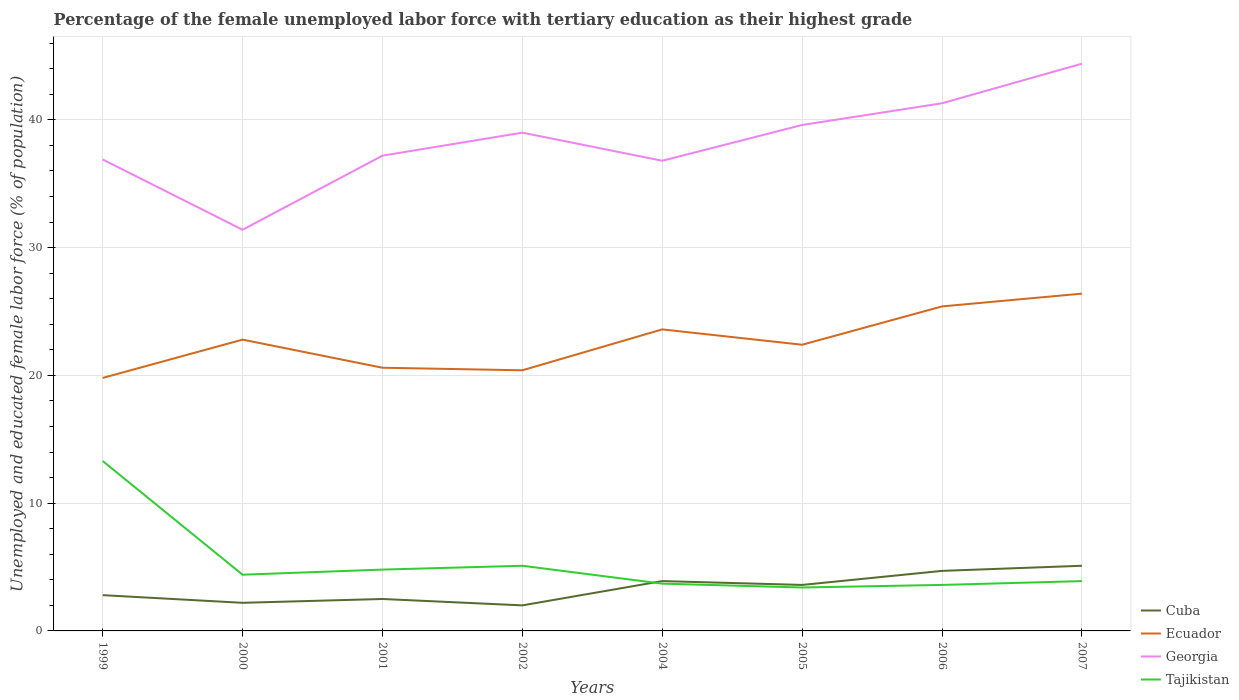How many different coloured lines are there?
Your response must be concise. 4. Does the line corresponding to Ecuador intersect with the line corresponding to Georgia?
Make the answer very short. No. Across all years, what is the maximum percentage of the unemployed female labor force with tertiary education in Georgia?
Give a very brief answer. 31.4. In which year was the percentage of the unemployed female labor force with tertiary education in Cuba maximum?
Provide a short and direct response. 2002. What is the total percentage of the unemployed female labor force with tertiary education in Ecuador in the graph?
Provide a succinct answer. -2.8. What is the difference between the highest and the second highest percentage of the unemployed female labor force with tertiary education in Ecuador?
Provide a succinct answer. 6.6. Is the percentage of the unemployed female labor force with tertiary education in Tajikistan strictly greater than the percentage of the unemployed female labor force with tertiary education in Ecuador over the years?
Keep it short and to the point. Yes. How many years are there in the graph?
Keep it short and to the point. 8. Does the graph contain any zero values?
Keep it short and to the point. No. Where does the legend appear in the graph?
Your answer should be very brief. Bottom right. What is the title of the graph?
Keep it short and to the point. Percentage of the female unemployed labor force with tertiary education as their highest grade. What is the label or title of the X-axis?
Provide a short and direct response. Years. What is the label or title of the Y-axis?
Your answer should be very brief. Unemployed and educated female labor force (% of population). What is the Unemployed and educated female labor force (% of population) of Cuba in 1999?
Your answer should be compact. 2.8. What is the Unemployed and educated female labor force (% of population) in Ecuador in 1999?
Give a very brief answer. 19.8. What is the Unemployed and educated female labor force (% of population) in Georgia in 1999?
Keep it short and to the point. 36.9. What is the Unemployed and educated female labor force (% of population) in Tajikistan in 1999?
Keep it short and to the point. 13.3. What is the Unemployed and educated female labor force (% of population) of Cuba in 2000?
Make the answer very short. 2.2. What is the Unemployed and educated female labor force (% of population) of Ecuador in 2000?
Your answer should be compact. 22.8. What is the Unemployed and educated female labor force (% of population) of Georgia in 2000?
Give a very brief answer. 31.4. What is the Unemployed and educated female labor force (% of population) of Tajikistan in 2000?
Provide a short and direct response. 4.4. What is the Unemployed and educated female labor force (% of population) in Cuba in 2001?
Offer a very short reply. 2.5. What is the Unemployed and educated female labor force (% of population) in Ecuador in 2001?
Give a very brief answer. 20.6. What is the Unemployed and educated female labor force (% of population) in Georgia in 2001?
Offer a very short reply. 37.2. What is the Unemployed and educated female labor force (% of population) of Tajikistan in 2001?
Make the answer very short. 4.8. What is the Unemployed and educated female labor force (% of population) in Ecuador in 2002?
Your response must be concise. 20.4. What is the Unemployed and educated female labor force (% of population) of Tajikistan in 2002?
Provide a short and direct response. 5.1. What is the Unemployed and educated female labor force (% of population) of Cuba in 2004?
Give a very brief answer. 3.9. What is the Unemployed and educated female labor force (% of population) in Ecuador in 2004?
Provide a succinct answer. 23.6. What is the Unemployed and educated female labor force (% of population) in Georgia in 2004?
Provide a succinct answer. 36.8. What is the Unemployed and educated female labor force (% of population) of Tajikistan in 2004?
Offer a very short reply. 3.7. What is the Unemployed and educated female labor force (% of population) of Cuba in 2005?
Your response must be concise. 3.6. What is the Unemployed and educated female labor force (% of population) in Ecuador in 2005?
Make the answer very short. 22.4. What is the Unemployed and educated female labor force (% of population) in Georgia in 2005?
Give a very brief answer. 39.6. What is the Unemployed and educated female labor force (% of population) in Tajikistan in 2005?
Your response must be concise. 3.4. What is the Unemployed and educated female labor force (% of population) of Cuba in 2006?
Provide a succinct answer. 4.7. What is the Unemployed and educated female labor force (% of population) of Ecuador in 2006?
Your answer should be compact. 25.4. What is the Unemployed and educated female labor force (% of population) in Georgia in 2006?
Offer a very short reply. 41.3. What is the Unemployed and educated female labor force (% of population) in Tajikistan in 2006?
Your response must be concise. 3.6. What is the Unemployed and educated female labor force (% of population) of Cuba in 2007?
Your response must be concise. 5.1. What is the Unemployed and educated female labor force (% of population) of Ecuador in 2007?
Offer a very short reply. 26.4. What is the Unemployed and educated female labor force (% of population) of Georgia in 2007?
Offer a very short reply. 44.4. What is the Unemployed and educated female labor force (% of population) in Tajikistan in 2007?
Keep it short and to the point. 3.9. Across all years, what is the maximum Unemployed and educated female labor force (% of population) of Cuba?
Give a very brief answer. 5.1. Across all years, what is the maximum Unemployed and educated female labor force (% of population) in Ecuador?
Your response must be concise. 26.4. Across all years, what is the maximum Unemployed and educated female labor force (% of population) of Georgia?
Offer a terse response. 44.4. Across all years, what is the maximum Unemployed and educated female labor force (% of population) in Tajikistan?
Your response must be concise. 13.3. Across all years, what is the minimum Unemployed and educated female labor force (% of population) in Cuba?
Keep it short and to the point. 2. Across all years, what is the minimum Unemployed and educated female labor force (% of population) in Ecuador?
Your answer should be compact. 19.8. Across all years, what is the minimum Unemployed and educated female labor force (% of population) of Georgia?
Provide a short and direct response. 31.4. Across all years, what is the minimum Unemployed and educated female labor force (% of population) of Tajikistan?
Your answer should be very brief. 3.4. What is the total Unemployed and educated female labor force (% of population) of Cuba in the graph?
Your response must be concise. 26.8. What is the total Unemployed and educated female labor force (% of population) of Ecuador in the graph?
Provide a short and direct response. 181.4. What is the total Unemployed and educated female labor force (% of population) in Georgia in the graph?
Provide a short and direct response. 306.6. What is the total Unemployed and educated female labor force (% of population) in Tajikistan in the graph?
Keep it short and to the point. 42.2. What is the difference between the Unemployed and educated female labor force (% of population) in Tajikistan in 1999 and that in 2000?
Make the answer very short. 8.9. What is the difference between the Unemployed and educated female labor force (% of population) of Tajikistan in 1999 and that in 2001?
Your answer should be very brief. 8.5. What is the difference between the Unemployed and educated female labor force (% of population) of Cuba in 1999 and that in 2002?
Provide a succinct answer. 0.8. What is the difference between the Unemployed and educated female labor force (% of population) in Ecuador in 1999 and that in 2002?
Provide a short and direct response. -0.6. What is the difference between the Unemployed and educated female labor force (% of population) of Georgia in 1999 and that in 2002?
Give a very brief answer. -2.1. What is the difference between the Unemployed and educated female labor force (% of population) in Tajikistan in 1999 and that in 2002?
Offer a terse response. 8.2. What is the difference between the Unemployed and educated female labor force (% of population) of Ecuador in 1999 and that in 2004?
Provide a succinct answer. -3.8. What is the difference between the Unemployed and educated female labor force (% of population) of Cuba in 1999 and that in 2005?
Give a very brief answer. -0.8. What is the difference between the Unemployed and educated female labor force (% of population) in Georgia in 1999 and that in 2005?
Keep it short and to the point. -2.7. What is the difference between the Unemployed and educated female labor force (% of population) in Cuba in 1999 and that in 2006?
Ensure brevity in your answer.  -1.9. What is the difference between the Unemployed and educated female labor force (% of population) of Georgia in 1999 and that in 2006?
Make the answer very short. -4.4. What is the difference between the Unemployed and educated female labor force (% of population) of Tajikistan in 1999 and that in 2006?
Your answer should be compact. 9.7. What is the difference between the Unemployed and educated female labor force (% of population) of Tajikistan in 1999 and that in 2007?
Give a very brief answer. 9.4. What is the difference between the Unemployed and educated female labor force (% of population) of Cuba in 2000 and that in 2001?
Make the answer very short. -0.3. What is the difference between the Unemployed and educated female labor force (% of population) of Georgia in 2000 and that in 2001?
Give a very brief answer. -5.8. What is the difference between the Unemployed and educated female labor force (% of population) of Georgia in 2000 and that in 2002?
Keep it short and to the point. -7.6. What is the difference between the Unemployed and educated female labor force (% of population) of Tajikistan in 2000 and that in 2002?
Your answer should be compact. -0.7. What is the difference between the Unemployed and educated female labor force (% of population) in Georgia in 2000 and that in 2004?
Provide a short and direct response. -5.4. What is the difference between the Unemployed and educated female labor force (% of population) of Tajikistan in 2000 and that in 2004?
Your answer should be compact. 0.7. What is the difference between the Unemployed and educated female labor force (% of population) in Georgia in 2000 and that in 2005?
Offer a very short reply. -8.2. What is the difference between the Unemployed and educated female labor force (% of population) in Tajikistan in 2000 and that in 2006?
Ensure brevity in your answer.  0.8. What is the difference between the Unemployed and educated female labor force (% of population) of Tajikistan in 2000 and that in 2007?
Ensure brevity in your answer.  0.5. What is the difference between the Unemployed and educated female labor force (% of population) of Ecuador in 2001 and that in 2002?
Your answer should be compact. 0.2. What is the difference between the Unemployed and educated female labor force (% of population) in Tajikistan in 2001 and that in 2002?
Provide a short and direct response. -0.3. What is the difference between the Unemployed and educated female labor force (% of population) in Tajikistan in 2001 and that in 2004?
Offer a very short reply. 1.1. What is the difference between the Unemployed and educated female labor force (% of population) in Cuba in 2001 and that in 2005?
Provide a short and direct response. -1.1. What is the difference between the Unemployed and educated female labor force (% of population) of Tajikistan in 2001 and that in 2005?
Ensure brevity in your answer.  1.4. What is the difference between the Unemployed and educated female labor force (% of population) in Ecuador in 2001 and that in 2006?
Give a very brief answer. -4.8. What is the difference between the Unemployed and educated female labor force (% of population) of Georgia in 2001 and that in 2006?
Offer a very short reply. -4.1. What is the difference between the Unemployed and educated female labor force (% of population) in Tajikistan in 2001 and that in 2006?
Keep it short and to the point. 1.2. What is the difference between the Unemployed and educated female labor force (% of population) in Tajikistan in 2001 and that in 2007?
Your response must be concise. 0.9. What is the difference between the Unemployed and educated female labor force (% of population) in Georgia in 2002 and that in 2004?
Ensure brevity in your answer.  2.2. What is the difference between the Unemployed and educated female labor force (% of population) of Cuba in 2002 and that in 2005?
Make the answer very short. -1.6. What is the difference between the Unemployed and educated female labor force (% of population) in Tajikistan in 2002 and that in 2005?
Offer a very short reply. 1.7. What is the difference between the Unemployed and educated female labor force (% of population) in Cuba in 2002 and that in 2006?
Make the answer very short. -2.7. What is the difference between the Unemployed and educated female labor force (% of population) in Ecuador in 2002 and that in 2006?
Offer a very short reply. -5. What is the difference between the Unemployed and educated female labor force (% of population) of Georgia in 2002 and that in 2006?
Offer a terse response. -2.3. What is the difference between the Unemployed and educated female labor force (% of population) in Tajikistan in 2002 and that in 2006?
Make the answer very short. 1.5. What is the difference between the Unemployed and educated female labor force (% of population) of Ecuador in 2002 and that in 2007?
Your answer should be very brief. -6. What is the difference between the Unemployed and educated female labor force (% of population) of Georgia in 2002 and that in 2007?
Offer a terse response. -5.4. What is the difference between the Unemployed and educated female labor force (% of population) of Tajikistan in 2004 and that in 2005?
Your answer should be very brief. 0.3. What is the difference between the Unemployed and educated female labor force (% of population) of Cuba in 2004 and that in 2006?
Make the answer very short. -0.8. What is the difference between the Unemployed and educated female labor force (% of population) of Ecuador in 2004 and that in 2006?
Offer a very short reply. -1.8. What is the difference between the Unemployed and educated female labor force (% of population) of Georgia in 2004 and that in 2006?
Provide a succinct answer. -4.5. What is the difference between the Unemployed and educated female labor force (% of population) of Tajikistan in 2004 and that in 2007?
Make the answer very short. -0.2. What is the difference between the Unemployed and educated female labor force (% of population) of Ecuador in 2005 and that in 2006?
Keep it short and to the point. -3. What is the difference between the Unemployed and educated female labor force (% of population) in Tajikistan in 2005 and that in 2006?
Ensure brevity in your answer.  -0.2. What is the difference between the Unemployed and educated female labor force (% of population) of Cuba in 2005 and that in 2007?
Your response must be concise. -1.5. What is the difference between the Unemployed and educated female labor force (% of population) in Ecuador in 2005 and that in 2007?
Give a very brief answer. -4. What is the difference between the Unemployed and educated female labor force (% of population) in Georgia in 2005 and that in 2007?
Your response must be concise. -4.8. What is the difference between the Unemployed and educated female labor force (% of population) of Cuba in 2006 and that in 2007?
Your response must be concise. -0.4. What is the difference between the Unemployed and educated female labor force (% of population) in Georgia in 2006 and that in 2007?
Provide a succinct answer. -3.1. What is the difference between the Unemployed and educated female labor force (% of population) of Tajikistan in 2006 and that in 2007?
Ensure brevity in your answer.  -0.3. What is the difference between the Unemployed and educated female labor force (% of population) of Cuba in 1999 and the Unemployed and educated female labor force (% of population) of Ecuador in 2000?
Provide a short and direct response. -20. What is the difference between the Unemployed and educated female labor force (% of population) of Cuba in 1999 and the Unemployed and educated female labor force (% of population) of Georgia in 2000?
Your response must be concise. -28.6. What is the difference between the Unemployed and educated female labor force (% of population) of Cuba in 1999 and the Unemployed and educated female labor force (% of population) of Tajikistan in 2000?
Your answer should be very brief. -1.6. What is the difference between the Unemployed and educated female labor force (% of population) of Ecuador in 1999 and the Unemployed and educated female labor force (% of population) of Georgia in 2000?
Offer a very short reply. -11.6. What is the difference between the Unemployed and educated female labor force (% of population) in Ecuador in 1999 and the Unemployed and educated female labor force (% of population) in Tajikistan in 2000?
Your answer should be very brief. 15.4. What is the difference between the Unemployed and educated female labor force (% of population) in Georgia in 1999 and the Unemployed and educated female labor force (% of population) in Tajikistan in 2000?
Keep it short and to the point. 32.5. What is the difference between the Unemployed and educated female labor force (% of population) of Cuba in 1999 and the Unemployed and educated female labor force (% of population) of Ecuador in 2001?
Ensure brevity in your answer.  -17.8. What is the difference between the Unemployed and educated female labor force (% of population) of Cuba in 1999 and the Unemployed and educated female labor force (% of population) of Georgia in 2001?
Ensure brevity in your answer.  -34.4. What is the difference between the Unemployed and educated female labor force (% of population) in Cuba in 1999 and the Unemployed and educated female labor force (% of population) in Tajikistan in 2001?
Your response must be concise. -2. What is the difference between the Unemployed and educated female labor force (% of population) of Ecuador in 1999 and the Unemployed and educated female labor force (% of population) of Georgia in 2001?
Ensure brevity in your answer.  -17.4. What is the difference between the Unemployed and educated female labor force (% of population) in Ecuador in 1999 and the Unemployed and educated female labor force (% of population) in Tajikistan in 2001?
Your answer should be very brief. 15. What is the difference between the Unemployed and educated female labor force (% of population) in Georgia in 1999 and the Unemployed and educated female labor force (% of population) in Tajikistan in 2001?
Give a very brief answer. 32.1. What is the difference between the Unemployed and educated female labor force (% of population) in Cuba in 1999 and the Unemployed and educated female labor force (% of population) in Ecuador in 2002?
Your answer should be very brief. -17.6. What is the difference between the Unemployed and educated female labor force (% of population) of Cuba in 1999 and the Unemployed and educated female labor force (% of population) of Georgia in 2002?
Your response must be concise. -36.2. What is the difference between the Unemployed and educated female labor force (% of population) in Cuba in 1999 and the Unemployed and educated female labor force (% of population) in Tajikistan in 2002?
Provide a succinct answer. -2.3. What is the difference between the Unemployed and educated female labor force (% of population) in Ecuador in 1999 and the Unemployed and educated female labor force (% of population) in Georgia in 2002?
Your answer should be very brief. -19.2. What is the difference between the Unemployed and educated female labor force (% of population) of Ecuador in 1999 and the Unemployed and educated female labor force (% of population) of Tajikistan in 2002?
Provide a short and direct response. 14.7. What is the difference between the Unemployed and educated female labor force (% of population) of Georgia in 1999 and the Unemployed and educated female labor force (% of population) of Tajikistan in 2002?
Make the answer very short. 31.8. What is the difference between the Unemployed and educated female labor force (% of population) of Cuba in 1999 and the Unemployed and educated female labor force (% of population) of Ecuador in 2004?
Your answer should be compact. -20.8. What is the difference between the Unemployed and educated female labor force (% of population) of Cuba in 1999 and the Unemployed and educated female labor force (% of population) of Georgia in 2004?
Offer a terse response. -34. What is the difference between the Unemployed and educated female labor force (% of population) of Ecuador in 1999 and the Unemployed and educated female labor force (% of population) of Georgia in 2004?
Give a very brief answer. -17. What is the difference between the Unemployed and educated female labor force (% of population) of Ecuador in 1999 and the Unemployed and educated female labor force (% of population) of Tajikistan in 2004?
Provide a short and direct response. 16.1. What is the difference between the Unemployed and educated female labor force (% of population) of Georgia in 1999 and the Unemployed and educated female labor force (% of population) of Tajikistan in 2004?
Ensure brevity in your answer.  33.2. What is the difference between the Unemployed and educated female labor force (% of population) in Cuba in 1999 and the Unemployed and educated female labor force (% of population) in Ecuador in 2005?
Offer a very short reply. -19.6. What is the difference between the Unemployed and educated female labor force (% of population) in Cuba in 1999 and the Unemployed and educated female labor force (% of population) in Georgia in 2005?
Provide a short and direct response. -36.8. What is the difference between the Unemployed and educated female labor force (% of population) in Ecuador in 1999 and the Unemployed and educated female labor force (% of population) in Georgia in 2005?
Your response must be concise. -19.8. What is the difference between the Unemployed and educated female labor force (% of population) of Georgia in 1999 and the Unemployed and educated female labor force (% of population) of Tajikistan in 2005?
Give a very brief answer. 33.5. What is the difference between the Unemployed and educated female labor force (% of population) of Cuba in 1999 and the Unemployed and educated female labor force (% of population) of Ecuador in 2006?
Make the answer very short. -22.6. What is the difference between the Unemployed and educated female labor force (% of population) of Cuba in 1999 and the Unemployed and educated female labor force (% of population) of Georgia in 2006?
Your answer should be compact. -38.5. What is the difference between the Unemployed and educated female labor force (% of population) of Cuba in 1999 and the Unemployed and educated female labor force (% of population) of Tajikistan in 2006?
Your response must be concise. -0.8. What is the difference between the Unemployed and educated female labor force (% of population) in Ecuador in 1999 and the Unemployed and educated female labor force (% of population) in Georgia in 2006?
Offer a very short reply. -21.5. What is the difference between the Unemployed and educated female labor force (% of population) in Ecuador in 1999 and the Unemployed and educated female labor force (% of population) in Tajikistan in 2006?
Your answer should be compact. 16.2. What is the difference between the Unemployed and educated female labor force (% of population) in Georgia in 1999 and the Unemployed and educated female labor force (% of population) in Tajikistan in 2006?
Give a very brief answer. 33.3. What is the difference between the Unemployed and educated female labor force (% of population) in Cuba in 1999 and the Unemployed and educated female labor force (% of population) in Ecuador in 2007?
Ensure brevity in your answer.  -23.6. What is the difference between the Unemployed and educated female labor force (% of population) of Cuba in 1999 and the Unemployed and educated female labor force (% of population) of Georgia in 2007?
Your answer should be compact. -41.6. What is the difference between the Unemployed and educated female labor force (% of population) in Ecuador in 1999 and the Unemployed and educated female labor force (% of population) in Georgia in 2007?
Ensure brevity in your answer.  -24.6. What is the difference between the Unemployed and educated female labor force (% of population) of Ecuador in 1999 and the Unemployed and educated female labor force (% of population) of Tajikistan in 2007?
Your answer should be very brief. 15.9. What is the difference between the Unemployed and educated female labor force (% of population) of Georgia in 1999 and the Unemployed and educated female labor force (% of population) of Tajikistan in 2007?
Make the answer very short. 33. What is the difference between the Unemployed and educated female labor force (% of population) in Cuba in 2000 and the Unemployed and educated female labor force (% of population) in Ecuador in 2001?
Provide a short and direct response. -18.4. What is the difference between the Unemployed and educated female labor force (% of population) of Cuba in 2000 and the Unemployed and educated female labor force (% of population) of Georgia in 2001?
Provide a succinct answer. -35. What is the difference between the Unemployed and educated female labor force (% of population) in Cuba in 2000 and the Unemployed and educated female labor force (% of population) in Tajikistan in 2001?
Make the answer very short. -2.6. What is the difference between the Unemployed and educated female labor force (% of population) in Ecuador in 2000 and the Unemployed and educated female labor force (% of population) in Georgia in 2001?
Provide a short and direct response. -14.4. What is the difference between the Unemployed and educated female labor force (% of population) of Ecuador in 2000 and the Unemployed and educated female labor force (% of population) of Tajikistan in 2001?
Ensure brevity in your answer.  18. What is the difference between the Unemployed and educated female labor force (% of population) in Georgia in 2000 and the Unemployed and educated female labor force (% of population) in Tajikistan in 2001?
Your answer should be compact. 26.6. What is the difference between the Unemployed and educated female labor force (% of population) in Cuba in 2000 and the Unemployed and educated female labor force (% of population) in Ecuador in 2002?
Your answer should be compact. -18.2. What is the difference between the Unemployed and educated female labor force (% of population) in Cuba in 2000 and the Unemployed and educated female labor force (% of population) in Georgia in 2002?
Your answer should be compact. -36.8. What is the difference between the Unemployed and educated female labor force (% of population) of Ecuador in 2000 and the Unemployed and educated female labor force (% of population) of Georgia in 2002?
Ensure brevity in your answer.  -16.2. What is the difference between the Unemployed and educated female labor force (% of population) in Ecuador in 2000 and the Unemployed and educated female labor force (% of population) in Tajikistan in 2002?
Ensure brevity in your answer.  17.7. What is the difference between the Unemployed and educated female labor force (% of population) in Georgia in 2000 and the Unemployed and educated female labor force (% of population) in Tajikistan in 2002?
Offer a very short reply. 26.3. What is the difference between the Unemployed and educated female labor force (% of population) in Cuba in 2000 and the Unemployed and educated female labor force (% of population) in Ecuador in 2004?
Provide a succinct answer. -21.4. What is the difference between the Unemployed and educated female labor force (% of population) of Cuba in 2000 and the Unemployed and educated female labor force (% of population) of Georgia in 2004?
Your answer should be compact. -34.6. What is the difference between the Unemployed and educated female labor force (% of population) in Cuba in 2000 and the Unemployed and educated female labor force (% of population) in Tajikistan in 2004?
Make the answer very short. -1.5. What is the difference between the Unemployed and educated female labor force (% of population) in Ecuador in 2000 and the Unemployed and educated female labor force (% of population) in Georgia in 2004?
Provide a short and direct response. -14. What is the difference between the Unemployed and educated female labor force (% of population) of Ecuador in 2000 and the Unemployed and educated female labor force (% of population) of Tajikistan in 2004?
Keep it short and to the point. 19.1. What is the difference between the Unemployed and educated female labor force (% of population) of Georgia in 2000 and the Unemployed and educated female labor force (% of population) of Tajikistan in 2004?
Offer a very short reply. 27.7. What is the difference between the Unemployed and educated female labor force (% of population) of Cuba in 2000 and the Unemployed and educated female labor force (% of population) of Ecuador in 2005?
Keep it short and to the point. -20.2. What is the difference between the Unemployed and educated female labor force (% of population) in Cuba in 2000 and the Unemployed and educated female labor force (% of population) in Georgia in 2005?
Offer a terse response. -37.4. What is the difference between the Unemployed and educated female labor force (% of population) of Ecuador in 2000 and the Unemployed and educated female labor force (% of population) of Georgia in 2005?
Give a very brief answer. -16.8. What is the difference between the Unemployed and educated female labor force (% of population) in Cuba in 2000 and the Unemployed and educated female labor force (% of population) in Ecuador in 2006?
Your answer should be compact. -23.2. What is the difference between the Unemployed and educated female labor force (% of population) of Cuba in 2000 and the Unemployed and educated female labor force (% of population) of Georgia in 2006?
Your response must be concise. -39.1. What is the difference between the Unemployed and educated female labor force (% of population) of Ecuador in 2000 and the Unemployed and educated female labor force (% of population) of Georgia in 2006?
Give a very brief answer. -18.5. What is the difference between the Unemployed and educated female labor force (% of population) in Ecuador in 2000 and the Unemployed and educated female labor force (% of population) in Tajikistan in 2006?
Offer a terse response. 19.2. What is the difference between the Unemployed and educated female labor force (% of population) in Georgia in 2000 and the Unemployed and educated female labor force (% of population) in Tajikistan in 2006?
Make the answer very short. 27.8. What is the difference between the Unemployed and educated female labor force (% of population) in Cuba in 2000 and the Unemployed and educated female labor force (% of population) in Ecuador in 2007?
Your answer should be compact. -24.2. What is the difference between the Unemployed and educated female labor force (% of population) in Cuba in 2000 and the Unemployed and educated female labor force (% of population) in Georgia in 2007?
Ensure brevity in your answer.  -42.2. What is the difference between the Unemployed and educated female labor force (% of population) of Cuba in 2000 and the Unemployed and educated female labor force (% of population) of Tajikistan in 2007?
Keep it short and to the point. -1.7. What is the difference between the Unemployed and educated female labor force (% of population) of Ecuador in 2000 and the Unemployed and educated female labor force (% of population) of Georgia in 2007?
Offer a very short reply. -21.6. What is the difference between the Unemployed and educated female labor force (% of population) of Cuba in 2001 and the Unemployed and educated female labor force (% of population) of Ecuador in 2002?
Make the answer very short. -17.9. What is the difference between the Unemployed and educated female labor force (% of population) of Cuba in 2001 and the Unemployed and educated female labor force (% of population) of Georgia in 2002?
Provide a short and direct response. -36.5. What is the difference between the Unemployed and educated female labor force (% of population) in Cuba in 2001 and the Unemployed and educated female labor force (% of population) in Tajikistan in 2002?
Provide a succinct answer. -2.6. What is the difference between the Unemployed and educated female labor force (% of population) of Ecuador in 2001 and the Unemployed and educated female labor force (% of population) of Georgia in 2002?
Your answer should be very brief. -18.4. What is the difference between the Unemployed and educated female labor force (% of population) of Ecuador in 2001 and the Unemployed and educated female labor force (% of population) of Tajikistan in 2002?
Ensure brevity in your answer.  15.5. What is the difference between the Unemployed and educated female labor force (% of population) in Georgia in 2001 and the Unemployed and educated female labor force (% of population) in Tajikistan in 2002?
Ensure brevity in your answer.  32.1. What is the difference between the Unemployed and educated female labor force (% of population) in Cuba in 2001 and the Unemployed and educated female labor force (% of population) in Ecuador in 2004?
Your response must be concise. -21.1. What is the difference between the Unemployed and educated female labor force (% of population) of Cuba in 2001 and the Unemployed and educated female labor force (% of population) of Georgia in 2004?
Your response must be concise. -34.3. What is the difference between the Unemployed and educated female labor force (% of population) of Cuba in 2001 and the Unemployed and educated female labor force (% of population) of Tajikistan in 2004?
Your answer should be compact. -1.2. What is the difference between the Unemployed and educated female labor force (% of population) of Ecuador in 2001 and the Unemployed and educated female labor force (% of population) of Georgia in 2004?
Your response must be concise. -16.2. What is the difference between the Unemployed and educated female labor force (% of population) of Georgia in 2001 and the Unemployed and educated female labor force (% of population) of Tajikistan in 2004?
Make the answer very short. 33.5. What is the difference between the Unemployed and educated female labor force (% of population) of Cuba in 2001 and the Unemployed and educated female labor force (% of population) of Ecuador in 2005?
Your response must be concise. -19.9. What is the difference between the Unemployed and educated female labor force (% of population) in Cuba in 2001 and the Unemployed and educated female labor force (% of population) in Georgia in 2005?
Your answer should be very brief. -37.1. What is the difference between the Unemployed and educated female labor force (% of population) of Cuba in 2001 and the Unemployed and educated female labor force (% of population) of Tajikistan in 2005?
Your answer should be very brief. -0.9. What is the difference between the Unemployed and educated female labor force (% of population) in Ecuador in 2001 and the Unemployed and educated female labor force (% of population) in Georgia in 2005?
Keep it short and to the point. -19. What is the difference between the Unemployed and educated female labor force (% of population) in Georgia in 2001 and the Unemployed and educated female labor force (% of population) in Tajikistan in 2005?
Provide a short and direct response. 33.8. What is the difference between the Unemployed and educated female labor force (% of population) of Cuba in 2001 and the Unemployed and educated female labor force (% of population) of Ecuador in 2006?
Make the answer very short. -22.9. What is the difference between the Unemployed and educated female labor force (% of population) in Cuba in 2001 and the Unemployed and educated female labor force (% of population) in Georgia in 2006?
Give a very brief answer. -38.8. What is the difference between the Unemployed and educated female labor force (% of population) in Cuba in 2001 and the Unemployed and educated female labor force (% of population) in Tajikistan in 2006?
Your response must be concise. -1.1. What is the difference between the Unemployed and educated female labor force (% of population) of Ecuador in 2001 and the Unemployed and educated female labor force (% of population) of Georgia in 2006?
Offer a very short reply. -20.7. What is the difference between the Unemployed and educated female labor force (% of population) in Ecuador in 2001 and the Unemployed and educated female labor force (% of population) in Tajikistan in 2006?
Offer a terse response. 17. What is the difference between the Unemployed and educated female labor force (% of population) in Georgia in 2001 and the Unemployed and educated female labor force (% of population) in Tajikistan in 2006?
Provide a short and direct response. 33.6. What is the difference between the Unemployed and educated female labor force (% of population) of Cuba in 2001 and the Unemployed and educated female labor force (% of population) of Ecuador in 2007?
Ensure brevity in your answer.  -23.9. What is the difference between the Unemployed and educated female labor force (% of population) of Cuba in 2001 and the Unemployed and educated female labor force (% of population) of Georgia in 2007?
Offer a terse response. -41.9. What is the difference between the Unemployed and educated female labor force (% of population) of Ecuador in 2001 and the Unemployed and educated female labor force (% of population) of Georgia in 2007?
Provide a succinct answer. -23.8. What is the difference between the Unemployed and educated female labor force (% of population) in Georgia in 2001 and the Unemployed and educated female labor force (% of population) in Tajikistan in 2007?
Provide a succinct answer. 33.3. What is the difference between the Unemployed and educated female labor force (% of population) of Cuba in 2002 and the Unemployed and educated female labor force (% of population) of Ecuador in 2004?
Make the answer very short. -21.6. What is the difference between the Unemployed and educated female labor force (% of population) in Cuba in 2002 and the Unemployed and educated female labor force (% of population) in Georgia in 2004?
Offer a terse response. -34.8. What is the difference between the Unemployed and educated female labor force (% of population) of Ecuador in 2002 and the Unemployed and educated female labor force (% of population) of Georgia in 2004?
Provide a succinct answer. -16.4. What is the difference between the Unemployed and educated female labor force (% of population) in Georgia in 2002 and the Unemployed and educated female labor force (% of population) in Tajikistan in 2004?
Provide a short and direct response. 35.3. What is the difference between the Unemployed and educated female labor force (% of population) in Cuba in 2002 and the Unemployed and educated female labor force (% of population) in Ecuador in 2005?
Ensure brevity in your answer.  -20.4. What is the difference between the Unemployed and educated female labor force (% of population) in Cuba in 2002 and the Unemployed and educated female labor force (% of population) in Georgia in 2005?
Your response must be concise. -37.6. What is the difference between the Unemployed and educated female labor force (% of population) in Ecuador in 2002 and the Unemployed and educated female labor force (% of population) in Georgia in 2005?
Provide a short and direct response. -19.2. What is the difference between the Unemployed and educated female labor force (% of population) of Ecuador in 2002 and the Unemployed and educated female labor force (% of population) of Tajikistan in 2005?
Your answer should be compact. 17. What is the difference between the Unemployed and educated female labor force (% of population) in Georgia in 2002 and the Unemployed and educated female labor force (% of population) in Tajikistan in 2005?
Make the answer very short. 35.6. What is the difference between the Unemployed and educated female labor force (% of population) in Cuba in 2002 and the Unemployed and educated female labor force (% of population) in Ecuador in 2006?
Your response must be concise. -23.4. What is the difference between the Unemployed and educated female labor force (% of population) of Cuba in 2002 and the Unemployed and educated female labor force (% of population) of Georgia in 2006?
Offer a terse response. -39.3. What is the difference between the Unemployed and educated female labor force (% of population) in Cuba in 2002 and the Unemployed and educated female labor force (% of population) in Tajikistan in 2006?
Provide a short and direct response. -1.6. What is the difference between the Unemployed and educated female labor force (% of population) in Ecuador in 2002 and the Unemployed and educated female labor force (% of population) in Georgia in 2006?
Keep it short and to the point. -20.9. What is the difference between the Unemployed and educated female labor force (% of population) of Georgia in 2002 and the Unemployed and educated female labor force (% of population) of Tajikistan in 2006?
Your answer should be very brief. 35.4. What is the difference between the Unemployed and educated female labor force (% of population) of Cuba in 2002 and the Unemployed and educated female labor force (% of population) of Ecuador in 2007?
Your answer should be compact. -24.4. What is the difference between the Unemployed and educated female labor force (% of population) of Cuba in 2002 and the Unemployed and educated female labor force (% of population) of Georgia in 2007?
Make the answer very short. -42.4. What is the difference between the Unemployed and educated female labor force (% of population) in Cuba in 2002 and the Unemployed and educated female labor force (% of population) in Tajikistan in 2007?
Keep it short and to the point. -1.9. What is the difference between the Unemployed and educated female labor force (% of population) in Ecuador in 2002 and the Unemployed and educated female labor force (% of population) in Georgia in 2007?
Offer a terse response. -24. What is the difference between the Unemployed and educated female labor force (% of population) of Ecuador in 2002 and the Unemployed and educated female labor force (% of population) of Tajikistan in 2007?
Your answer should be compact. 16.5. What is the difference between the Unemployed and educated female labor force (% of population) of Georgia in 2002 and the Unemployed and educated female labor force (% of population) of Tajikistan in 2007?
Your answer should be compact. 35.1. What is the difference between the Unemployed and educated female labor force (% of population) of Cuba in 2004 and the Unemployed and educated female labor force (% of population) of Ecuador in 2005?
Give a very brief answer. -18.5. What is the difference between the Unemployed and educated female labor force (% of population) in Cuba in 2004 and the Unemployed and educated female labor force (% of population) in Georgia in 2005?
Make the answer very short. -35.7. What is the difference between the Unemployed and educated female labor force (% of population) of Cuba in 2004 and the Unemployed and educated female labor force (% of population) of Tajikistan in 2005?
Keep it short and to the point. 0.5. What is the difference between the Unemployed and educated female labor force (% of population) in Ecuador in 2004 and the Unemployed and educated female labor force (% of population) in Tajikistan in 2005?
Your answer should be compact. 20.2. What is the difference between the Unemployed and educated female labor force (% of population) in Georgia in 2004 and the Unemployed and educated female labor force (% of population) in Tajikistan in 2005?
Offer a very short reply. 33.4. What is the difference between the Unemployed and educated female labor force (% of population) of Cuba in 2004 and the Unemployed and educated female labor force (% of population) of Ecuador in 2006?
Give a very brief answer. -21.5. What is the difference between the Unemployed and educated female labor force (% of population) in Cuba in 2004 and the Unemployed and educated female labor force (% of population) in Georgia in 2006?
Your answer should be very brief. -37.4. What is the difference between the Unemployed and educated female labor force (% of population) of Cuba in 2004 and the Unemployed and educated female labor force (% of population) of Tajikistan in 2006?
Provide a succinct answer. 0.3. What is the difference between the Unemployed and educated female labor force (% of population) of Ecuador in 2004 and the Unemployed and educated female labor force (% of population) of Georgia in 2006?
Offer a very short reply. -17.7. What is the difference between the Unemployed and educated female labor force (% of population) in Ecuador in 2004 and the Unemployed and educated female labor force (% of population) in Tajikistan in 2006?
Keep it short and to the point. 20. What is the difference between the Unemployed and educated female labor force (% of population) in Georgia in 2004 and the Unemployed and educated female labor force (% of population) in Tajikistan in 2006?
Your response must be concise. 33.2. What is the difference between the Unemployed and educated female labor force (% of population) in Cuba in 2004 and the Unemployed and educated female labor force (% of population) in Ecuador in 2007?
Make the answer very short. -22.5. What is the difference between the Unemployed and educated female labor force (% of population) of Cuba in 2004 and the Unemployed and educated female labor force (% of population) of Georgia in 2007?
Your response must be concise. -40.5. What is the difference between the Unemployed and educated female labor force (% of population) in Cuba in 2004 and the Unemployed and educated female labor force (% of population) in Tajikistan in 2007?
Keep it short and to the point. 0. What is the difference between the Unemployed and educated female labor force (% of population) of Ecuador in 2004 and the Unemployed and educated female labor force (% of population) of Georgia in 2007?
Offer a very short reply. -20.8. What is the difference between the Unemployed and educated female labor force (% of population) of Ecuador in 2004 and the Unemployed and educated female labor force (% of population) of Tajikistan in 2007?
Ensure brevity in your answer.  19.7. What is the difference between the Unemployed and educated female labor force (% of population) of Georgia in 2004 and the Unemployed and educated female labor force (% of population) of Tajikistan in 2007?
Give a very brief answer. 32.9. What is the difference between the Unemployed and educated female labor force (% of population) in Cuba in 2005 and the Unemployed and educated female labor force (% of population) in Ecuador in 2006?
Offer a very short reply. -21.8. What is the difference between the Unemployed and educated female labor force (% of population) in Cuba in 2005 and the Unemployed and educated female labor force (% of population) in Georgia in 2006?
Make the answer very short. -37.7. What is the difference between the Unemployed and educated female labor force (% of population) of Cuba in 2005 and the Unemployed and educated female labor force (% of population) of Tajikistan in 2006?
Keep it short and to the point. 0. What is the difference between the Unemployed and educated female labor force (% of population) of Ecuador in 2005 and the Unemployed and educated female labor force (% of population) of Georgia in 2006?
Keep it short and to the point. -18.9. What is the difference between the Unemployed and educated female labor force (% of population) in Cuba in 2005 and the Unemployed and educated female labor force (% of population) in Ecuador in 2007?
Offer a very short reply. -22.8. What is the difference between the Unemployed and educated female labor force (% of population) of Cuba in 2005 and the Unemployed and educated female labor force (% of population) of Georgia in 2007?
Keep it short and to the point. -40.8. What is the difference between the Unemployed and educated female labor force (% of population) of Cuba in 2005 and the Unemployed and educated female labor force (% of population) of Tajikistan in 2007?
Keep it short and to the point. -0.3. What is the difference between the Unemployed and educated female labor force (% of population) of Georgia in 2005 and the Unemployed and educated female labor force (% of population) of Tajikistan in 2007?
Your answer should be compact. 35.7. What is the difference between the Unemployed and educated female labor force (% of population) in Cuba in 2006 and the Unemployed and educated female labor force (% of population) in Ecuador in 2007?
Your answer should be compact. -21.7. What is the difference between the Unemployed and educated female labor force (% of population) of Cuba in 2006 and the Unemployed and educated female labor force (% of population) of Georgia in 2007?
Offer a very short reply. -39.7. What is the difference between the Unemployed and educated female labor force (% of population) in Cuba in 2006 and the Unemployed and educated female labor force (% of population) in Tajikistan in 2007?
Provide a short and direct response. 0.8. What is the difference between the Unemployed and educated female labor force (% of population) of Georgia in 2006 and the Unemployed and educated female labor force (% of population) of Tajikistan in 2007?
Offer a terse response. 37.4. What is the average Unemployed and educated female labor force (% of population) in Cuba per year?
Offer a very short reply. 3.35. What is the average Unemployed and educated female labor force (% of population) of Ecuador per year?
Keep it short and to the point. 22.68. What is the average Unemployed and educated female labor force (% of population) in Georgia per year?
Provide a succinct answer. 38.33. What is the average Unemployed and educated female labor force (% of population) in Tajikistan per year?
Offer a terse response. 5.28. In the year 1999, what is the difference between the Unemployed and educated female labor force (% of population) in Cuba and Unemployed and educated female labor force (% of population) in Ecuador?
Make the answer very short. -17. In the year 1999, what is the difference between the Unemployed and educated female labor force (% of population) in Cuba and Unemployed and educated female labor force (% of population) in Georgia?
Give a very brief answer. -34.1. In the year 1999, what is the difference between the Unemployed and educated female labor force (% of population) of Ecuador and Unemployed and educated female labor force (% of population) of Georgia?
Keep it short and to the point. -17.1. In the year 1999, what is the difference between the Unemployed and educated female labor force (% of population) of Georgia and Unemployed and educated female labor force (% of population) of Tajikistan?
Your answer should be compact. 23.6. In the year 2000, what is the difference between the Unemployed and educated female labor force (% of population) in Cuba and Unemployed and educated female labor force (% of population) in Ecuador?
Provide a succinct answer. -20.6. In the year 2000, what is the difference between the Unemployed and educated female labor force (% of population) of Cuba and Unemployed and educated female labor force (% of population) of Georgia?
Give a very brief answer. -29.2. In the year 2000, what is the difference between the Unemployed and educated female labor force (% of population) of Cuba and Unemployed and educated female labor force (% of population) of Tajikistan?
Your answer should be very brief. -2.2. In the year 2000, what is the difference between the Unemployed and educated female labor force (% of population) of Ecuador and Unemployed and educated female labor force (% of population) of Georgia?
Your answer should be compact. -8.6. In the year 2000, what is the difference between the Unemployed and educated female labor force (% of population) of Ecuador and Unemployed and educated female labor force (% of population) of Tajikistan?
Ensure brevity in your answer.  18.4. In the year 2001, what is the difference between the Unemployed and educated female labor force (% of population) of Cuba and Unemployed and educated female labor force (% of population) of Ecuador?
Provide a short and direct response. -18.1. In the year 2001, what is the difference between the Unemployed and educated female labor force (% of population) of Cuba and Unemployed and educated female labor force (% of population) of Georgia?
Provide a short and direct response. -34.7. In the year 2001, what is the difference between the Unemployed and educated female labor force (% of population) of Cuba and Unemployed and educated female labor force (% of population) of Tajikistan?
Provide a succinct answer. -2.3. In the year 2001, what is the difference between the Unemployed and educated female labor force (% of population) in Ecuador and Unemployed and educated female labor force (% of population) in Georgia?
Provide a succinct answer. -16.6. In the year 2001, what is the difference between the Unemployed and educated female labor force (% of population) of Ecuador and Unemployed and educated female labor force (% of population) of Tajikistan?
Keep it short and to the point. 15.8. In the year 2001, what is the difference between the Unemployed and educated female labor force (% of population) of Georgia and Unemployed and educated female labor force (% of population) of Tajikistan?
Your response must be concise. 32.4. In the year 2002, what is the difference between the Unemployed and educated female labor force (% of population) of Cuba and Unemployed and educated female labor force (% of population) of Ecuador?
Your answer should be compact. -18.4. In the year 2002, what is the difference between the Unemployed and educated female labor force (% of population) of Cuba and Unemployed and educated female labor force (% of population) of Georgia?
Your response must be concise. -37. In the year 2002, what is the difference between the Unemployed and educated female labor force (% of population) of Ecuador and Unemployed and educated female labor force (% of population) of Georgia?
Your response must be concise. -18.6. In the year 2002, what is the difference between the Unemployed and educated female labor force (% of population) of Georgia and Unemployed and educated female labor force (% of population) of Tajikistan?
Keep it short and to the point. 33.9. In the year 2004, what is the difference between the Unemployed and educated female labor force (% of population) in Cuba and Unemployed and educated female labor force (% of population) in Ecuador?
Offer a terse response. -19.7. In the year 2004, what is the difference between the Unemployed and educated female labor force (% of population) of Cuba and Unemployed and educated female labor force (% of population) of Georgia?
Keep it short and to the point. -32.9. In the year 2004, what is the difference between the Unemployed and educated female labor force (% of population) of Ecuador and Unemployed and educated female labor force (% of population) of Georgia?
Your answer should be very brief. -13.2. In the year 2004, what is the difference between the Unemployed and educated female labor force (% of population) in Georgia and Unemployed and educated female labor force (% of population) in Tajikistan?
Your response must be concise. 33.1. In the year 2005, what is the difference between the Unemployed and educated female labor force (% of population) of Cuba and Unemployed and educated female labor force (% of population) of Ecuador?
Keep it short and to the point. -18.8. In the year 2005, what is the difference between the Unemployed and educated female labor force (% of population) in Cuba and Unemployed and educated female labor force (% of population) in Georgia?
Make the answer very short. -36. In the year 2005, what is the difference between the Unemployed and educated female labor force (% of population) in Ecuador and Unemployed and educated female labor force (% of population) in Georgia?
Make the answer very short. -17.2. In the year 2005, what is the difference between the Unemployed and educated female labor force (% of population) in Ecuador and Unemployed and educated female labor force (% of population) in Tajikistan?
Your answer should be very brief. 19. In the year 2005, what is the difference between the Unemployed and educated female labor force (% of population) of Georgia and Unemployed and educated female labor force (% of population) of Tajikistan?
Offer a very short reply. 36.2. In the year 2006, what is the difference between the Unemployed and educated female labor force (% of population) in Cuba and Unemployed and educated female labor force (% of population) in Ecuador?
Give a very brief answer. -20.7. In the year 2006, what is the difference between the Unemployed and educated female labor force (% of population) in Cuba and Unemployed and educated female labor force (% of population) in Georgia?
Your answer should be very brief. -36.6. In the year 2006, what is the difference between the Unemployed and educated female labor force (% of population) of Ecuador and Unemployed and educated female labor force (% of population) of Georgia?
Keep it short and to the point. -15.9. In the year 2006, what is the difference between the Unemployed and educated female labor force (% of population) in Ecuador and Unemployed and educated female labor force (% of population) in Tajikistan?
Your answer should be very brief. 21.8. In the year 2006, what is the difference between the Unemployed and educated female labor force (% of population) of Georgia and Unemployed and educated female labor force (% of population) of Tajikistan?
Give a very brief answer. 37.7. In the year 2007, what is the difference between the Unemployed and educated female labor force (% of population) of Cuba and Unemployed and educated female labor force (% of population) of Ecuador?
Your response must be concise. -21.3. In the year 2007, what is the difference between the Unemployed and educated female labor force (% of population) of Cuba and Unemployed and educated female labor force (% of population) of Georgia?
Your answer should be very brief. -39.3. In the year 2007, what is the difference between the Unemployed and educated female labor force (% of population) in Ecuador and Unemployed and educated female labor force (% of population) in Georgia?
Ensure brevity in your answer.  -18. In the year 2007, what is the difference between the Unemployed and educated female labor force (% of population) in Georgia and Unemployed and educated female labor force (% of population) in Tajikistan?
Provide a short and direct response. 40.5. What is the ratio of the Unemployed and educated female labor force (% of population) in Cuba in 1999 to that in 2000?
Ensure brevity in your answer.  1.27. What is the ratio of the Unemployed and educated female labor force (% of population) of Ecuador in 1999 to that in 2000?
Offer a very short reply. 0.87. What is the ratio of the Unemployed and educated female labor force (% of population) in Georgia in 1999 to that in 2000?
Offer a very short reply. 1.18. What is the ratio of the Unemployed and educated female labor force (% of population) of Tajikistan in 1999 to that in 2000?
Ensure brevity in your answer.  3.02. What is the ratio of the Unemployed and educated female labor force (% of population) of Cuba in 1999 to that in 2001?
Provide a succinct answer. 1.12. What is the ratio of the Unemployed and educated female labor force (% of population) of Ecuador in 1999 to that in 2001?
Provide a succinct answer. 0.96. What is the ratio of the Unemployed and educated female labor force (% of population) of Tajikistan in 1999 to that in 2001?
Your response must be concise. 2.77. What is the ratio of the Unemployed and educated female labor force (% of population) in Cuba in 1999 to that in 2002?
Offer a terse response. 1.4. What is the ratio of the Unemployed and educated female labor force (% of population) of Ecuador in 1999 to that in 2002?
Ensure brevity in your answer.  0.97. What is the ratio of the Unemployed and educated female labor force (% of population) in Georgia in 1999 to that in 2002?
Offer a very short reply. 0.95. What is the ratio of the Unemployed and educated female labor force (% of population) in Tajikistan in 1999 to that in 2002?
Ensure brevity in your answer.  2.61. What is the ratio of the Unemployed and educated female labor force (% of population) in Cuba in 1999 to that in 2004?
Make the answer very short. 0.72. What is the ratio of the Unemployed and educated female labor force (% of population) in Ecuador in 1999 to that in 2004?
Your answer should be very brief. 0.84. What is the ratio of the Unemployed and educated female labor force (% of population) in Georgia in 1999 to that in 2004?
Provide a succinct answer. 1. What is the ratio of the Unemployed and educated female labor force (% of population) of Tajikistan in 1999 to that in 2004?
Make the answer very short. 3.59. What is the ratio of the Unemployed and educated female labor force (% of population) of Cuba in 1999 to that in 2005?
Provide a short and direct response. 0.78. What is the ratio of the Unemployed and educated female labor force (% of population) of Ecuador in 1999 to that in 2005?
Provide a short and direct response. 0.88. What is the ratio of the Unemployed and educated female labor force (% of population) of Georgia in 1999 to that in 2005?
Offer a terse response. 0.93. What is the ratio of the Unemployed and educated female labor force (% of population) in Tajikistan in 1999 to that in 2005?
Make the answer very short. 3.91. What is the ratio of the Unemployed and educated female labor force (% of population) of Cuba in 1999 to that in 2006?
Provide a short and direct response. 0.6. What is the ratio of the Unemployed and educated female labor force (% of population) in Ecuador in 1999 to that in 2006?
Offer a terse response. 0.78. What is the ratio of the Unemployed and educated female labor force (% of population) of Georgia in 1999 to that in 2006?
Provide a succinct answer. 0.89. What is the ratio of the Unemployed and educated female labor force (% of population) of Tajikistan in 1999 to that in 2006?
Provide a short and direct response. 3.69. What is the ratio of the Unemployed and educated female labor force (% of population) of Cuba in 1999 to that in 2007?
Your response must be concise. 0.55. What is the ratio of the Unemployed and educated female labor force (% of population) in Ecuador in 1999 to that in 2007?
Make the answer very short. 0.75. What is the ratio of the Unemployed and educated female labor force (% of population) in Georgia in 1999 to that in 2007?
Your answer should be very brief. 0.83. What is the ratio of the Unemployed and educated female labor force (% of population) in Tajikistan in 1999 to that in 2007?
Make the answer very short. 3.41. What is the ratio of the Unemployed and educated female labor force (% of population) of Cuba in 2000 to that in 2001?
Provide a short and direct response. 0.88. What is the ratio of the Unemployed and educated female labor force (% of population) of Ecuador in 2000 to that in 2001?
Provide a short and direct response. 1.11. What is the ratio of the Unemployed and educated female labor force (% of population) of Georgia in 2000 to that in 2001?
Your answer should be very brief. 0.84. What is the ratio of the Unemployed and educated female labor force (% of population) of Tajikistan in 2000 to that in 2001?
Give a very brief answer. 0.92. What is the ratio of the Unemployed and educated female labor force (% of population) in Cuba in 2000 to that in 2002?
Offer a terse response. 1.1. What is the ratio of the Unemployed and educated female labor force (% of population) in Ecuador in 2000 to that in 2002?
Your response must be concise. 1.12. What is the ratio of the Unemployed and educated female labor force (% of population) of Georgia in 2000 to that in 2002?
Give a very brief answer. 0.81. What is the ratio of the Unemployed and educated female labor force (% of population) in Tajikistan in 2000 to that in 2002?
Offer a terse response. 0.86. What is the ratio of the Unemployed and educated female labor force (% of population) of Cuba in 2000 to that in 2004?
Make the answer very short. 0.56. What is the ratio of the Unemployed and educated female labor force (% of population) in Ecuador in 2000 to that in 2004?
Offer a very short reply. 0.97. What is the ratio of the Unemployed and educated female labor force (% of population) of Georgia in 2000 to that in 2004?
Your answer should be compact. 0.85. What is the ratio of the Unemployed and educated female labor force (% of population) in Tajikistan in 2000 to that in 2004?
Your answer should be compact. 1.19. What is the ratio of the Unemployed and educated female labor force (% of population) in Cuba in 2000 to that in 2005?
Offer a terse response. 0.61. What is the ratio of the Unemployed and educated female labor force (% of population) in Ecuador in 2000 to that in 2005?
Provide a succinct answer. 1.02. What is the ratio of the Unemployed and educated female labor force (% of population) of Georgia in 2000 to that in 2005?
Make the answer very short. 0.79. What is the ratio of the Unemployed and educated female labor force (% of population) of Tajikistan in 2000 to that in 2005?
Ensure brevity in your answer.  1.29. What is the ratio of the Unemployed and educated female labor force (% of population) in Cuba in 2000 to that in 2006?
Provide a short and direct response. 0.47. What is the ratio of the Unemployed and educated female labor force (% of population) in Ecuador in 2000 to that in 2006?
Ensure brevity in your answer.  0.9. What is the ratio of the Unemployed and educated female labor force (% of population) in Georgia in 2000 to that in 2006?
Make the answer very short. 0.76. What is the ratio of the Unemployed and educated female labor force (% of population) of Tajikistan in 2000 to that in 2006?
Ensure brevity in your answer.  1.22. What is the ratio of the Unemployed and educated female labor force (% of population) of Cuba in 2000 to that in 2007?
Offer a terse response. 0.43. What is the ratio of the Unemployed and educated female labor force (% of population) in Ecuador in 2000 to that in 2007?
Provide a short and direct response. 0.86. What is the ratio of the Unemployed and educated female labor force (% of population) in Georgia in 2000 to that in 2007?
Give a very brief answer. 0.71. What is the ratio of the Unemployed and educated female labor force (% of population) in Tajikistan in 2000 to that in 2007?
Provide a short and direct response. 1.13. What is the ratio of the Unemployed and educated female labor force (% of population) of Cuba in 2001 to that in 2002?
Make the answer very short. 1.25. What is the ratio of the Unemployed and educated female labor force (% of population) in Ecuador in 2001 to that in 2002?
Offer a terse response. 1.01. What is the ratio of the Unemployed and educated female labor force (% of population) of Georgia in 2001 to that in 2002?
Offer a very short reply. 0.95. What is the ratio of the Unemployed and educated female labor force (% of population) in Tajikistan in 2001 to that in 2002?
Provide a short and direct response. 0.94. What is the ratio of the Unemployed and educated female labor force (% of population) in Cuba in 2001 to that in 2004?
Provide a succinct answer. 0.64. What is the ratio of the Unemployed and educated female labor force (% of population) of Ecuador in 2001 to that in 2004?
Offer a terse response. 0.87. What is the ratio of the Unemployed and educated female labor force (% of population) of Georgia in 2001 to that in 2004?
Offer a very short reply. 1.01. What is the ratio of the Unemployed and educated female labor force (% of population) in Tajikistan in 2001 to that in 2004?
Offer a terse response. 1.3. What is the ratio of the Unemployed and educated female labor force (% of population) in Cuba in 2001 to that in 2005?
Ensure brevity in your answer.  0.69. What is the ratio of the Unemployed and educated female labor force (% of population) in Ecuador in 2001 to that in 2005?
Ensure brevity in your answer.  0.92. What is the ratio of the Unemployed and educated female labor force (% of population) of Georgia in 2001 to that in 2005?
Ensure brevity in your answer.  0.94. What is the ratio of the Unemployed and educated female labor force (% of population) of Tajikistan in 2001 to that in 2005?
Give a very brief answer. 1.41. What is the ratio of the Unemployed and educated female labor force (% of population) of Cuba in 2001 to that in 2006?
Offer a very short reply. 0.53. What is the ratio of the Unemployed and educated female labor force (% of population) of Ecuador in 2001 to that in 2006?
Your answer should be compact. 0.81. What is the ratio of the Unemployed and educated female labor force (% of population) in Georgia in 2001 to that in 2006?
Your answer should be very brief. 0.9. What is the ratio of the Unemployed and educated female labor force (% of population) in Cuba in 2001 to that in 2007?
Your answer should be very brief. 0.49. What is the ratio of the Unemployed and educated female labor force (% of population) of Ecuador in 2001 to that in 2007?
Your response must be concise. 0.78. What is the ratio of the Unemployed and educated female labor force (% of population) of Georgia in 2001 to that in 2007?
Make the answer very short. 0.84. What is the ratio of the Unemployed and educated female labor force (% of population) of Tajikistan in 2001 to that in 2007?
Keep it short and to the point. 1.23. What is the ratio of the Unemployed and educated female labor force (% of population) of Cuba in 2002 to that in 2004?
Offer a very short reply. 0.51. What is the ratio of the Unemployed and educated female labor force (% of population) in Ecuador in 2002 to that in 2004?
Make the answer very short. 0.86. What is the ratio of the Unemployed and educated female labor force (% of population) of Georgia in 2002 to that in 2004?
Ensure brevity in your answer.  1.06. What is the ratio of the Unemployed and educated female labor force (% of population) of Tajikistan in 2002 to that in 2004?
Offer a very short reply. 1.38. What is the ratio of the Unemployed and educated female labor force (% of population) in Cuba in 2002 to that in 2005?
Ensure brevity in your answer.  0.56. What is the ratio of the Unemployed and educated female labor force (% of population) in Ecuador in 2002 to that in 2005?
Your answer should be very brief. 0.91. What is the ratio of the Unemployed and educated female labor force (% of population) of Georgia in 2002 to that in 2005?
Provide a succinct answer. 0.98. What is the ratio of the Unemployed and educated female labor force (% of population) of Tajikistan in 2002 to that in 2005?
Provide a succinct answer. 1.5. What is the ratio of the Unemployed and educated female labor force (% of population) in Cuba in 2002 to that in 2006?
Your response must be concise. 0.43. What is the ratio of the Unemployed and educated female labor force (% of population) in Ecuador in 2002 to that in 2006?
Your answer should be compact. 0.8. What is the ratio of the Unemployed and educated female labor force (% of population) in Georgia in 2002 to that in 2006?
Ensure brevity in your answer.  0.94. What is the ratio of the Unemployed and educated female labor force (% of population) of Tajikistan in 2002 to that in 2006?
Your response must be concise. 1.42. What is the ratio of the Unemployed and educated female labor force (% of population) of Cuba in 2002 to that in 2007?
Make the answer very short. 0.39. What is the ratio of the Unemployed and educated female labor force (% of population) in Ecuador in 2002 to that in 2007?
Your response must be concise. 0.77. What is the ratio of the Unemployed and educated female labor force (% of population) of Georgia in 2002 to that in 2007?
Offer a very short reply. 0.88. What is the ratio of the Unemployed and educated female labor force (% of population) in Tajikistan in 2002 to that in 2007?
Your response must be concise. 1.31. What is the ratio of the Unemployed and educated female labor force (% of population) of Cuba in 2004 to that in 2005?
Keep it short and to the point. 1.08. What is the ratio of the Unemployed and educated female labor force (% of population) in Ecuador in 2004 to that in 2005?
Provide a succinct answer. 1.05. What is the ratio of the Unemployed and educated female labor force (% of population) of Georgia in 2004 to that in 2005?
Offer a very short reply. 0.93. What is the ratio of the Unemployed and educated female labor force (% of population) of Tajikistan in 2004 to that in 2005?
Offer a terse response. 1.09. What is the ratio of the Unemployed and educated female labor force (% of population) in Cuba in 2004 to that in 2006?
Give a very brief answer. 0.83. What is the ratio of the Unemployed and educated female labor force (% of population) of Ecuador in 2004 to that in 2006?
Provide a short and direct response. 0.93. What is the ratio of the Unemployed and educated female labor force (% of population) in Georgia in 2004 to that in 2006?
Make the answer very short. 0.89. What is the ratio of the Unemployed and educated female labor force (% of population) of Tajikistan in 2004 to that in 2006?
Your response must be concise. 1.03. What is the ratio of the Unemployed and educated female labor force (% of population) in Cuba in 2004 to that in 2007?
Offer a very short reply. 0.76. What is the ratio of the Unemployed and educated female labor force (% of population) of Ecuador in 2004 to that in 2007?
Provide a succinct answer. 0.89. What is the ratio of the Unemployed and educated female labor force (% of population) in Georgia in 2004 to that in 2007?
Offer a terse response. 0.83. What is the ratio of the Unemployed and educated female labor force (% of population) of Tajikistan in 2004 to that in 2007?
Provide a succinct answer. 0.95. What is the ratio of the Unemployed and educated female labor force (% of population) in Cuba in 2005 to that in 2006?
Offer a terse response. 0.77. What is the ratio of the Unemployed and educated female labor force (% of population) in Ecuador in 2005 to that in 2006?
Your answer should be compact. 0.88. What is the ratio of the Unemployed and educated female labor force (% of population) in Georgia in 2005 to that in 2006?
Your answer should be very brief. 0.96. What is the ratio of the Unemployed and educated female labor force (% of population) in Cuba in 2005 to that in 2007?
Offer a terse response. 0.71. What is the ratio of the Unemployed and educated female labor force (% of population) of Ecuador in 2005 to that in 2007?
Offer a very short reply. 0.85. What is the ratio of the Unemployed and educated female labor force (% of population) in Georgia in 2005 to that in 2007?
Give a very brief answer. 0.89. What is the ratio of the Unemployed and educated female labor force (% of population) of Tajikistan in 2005 to that in 2007?
Keep it short and to the point. 0.87. What is the ratio of the Unemployed and educated female labor force (% of population) in Cuba in 2006 to that in 2007?
Provide a succinct answer. 0.92. What is the ratio of the Unemployed and educated female labor force (% of population) in Ecuador in 2006 to that in 2007?
Give a very brief answer. 0.96. What is the ratio of the Unemployed and educated female labor force (% of population) of Georgia in 2006 to that in 2007?
Ensure brevity in your answer.  0.93. What is the difference between the highest and the second highest Unemployed and educated female labor force (% of population) in Georgia?
Make the answer very short. 3.1. What is the difference between the highest and the second highest Unemployed and educated female labor force (% of population) of Tajikistan?
Your response must be concise. 8.2. What is the difference between the highest and the lowest Unemployed and educated female labor force (% of population) of Cuba?
Your response must be concise. 3.1. What is the difference between the highest and the lowest Unemployed and educated female labor force (% of population) of Ecuador?
Offer a terse response. 6.6. What is the difference between the highest and the lowest Unemployed and educated female labor force (% of population) of Tajikistan?
Provide a succinct answer. 9.9. 